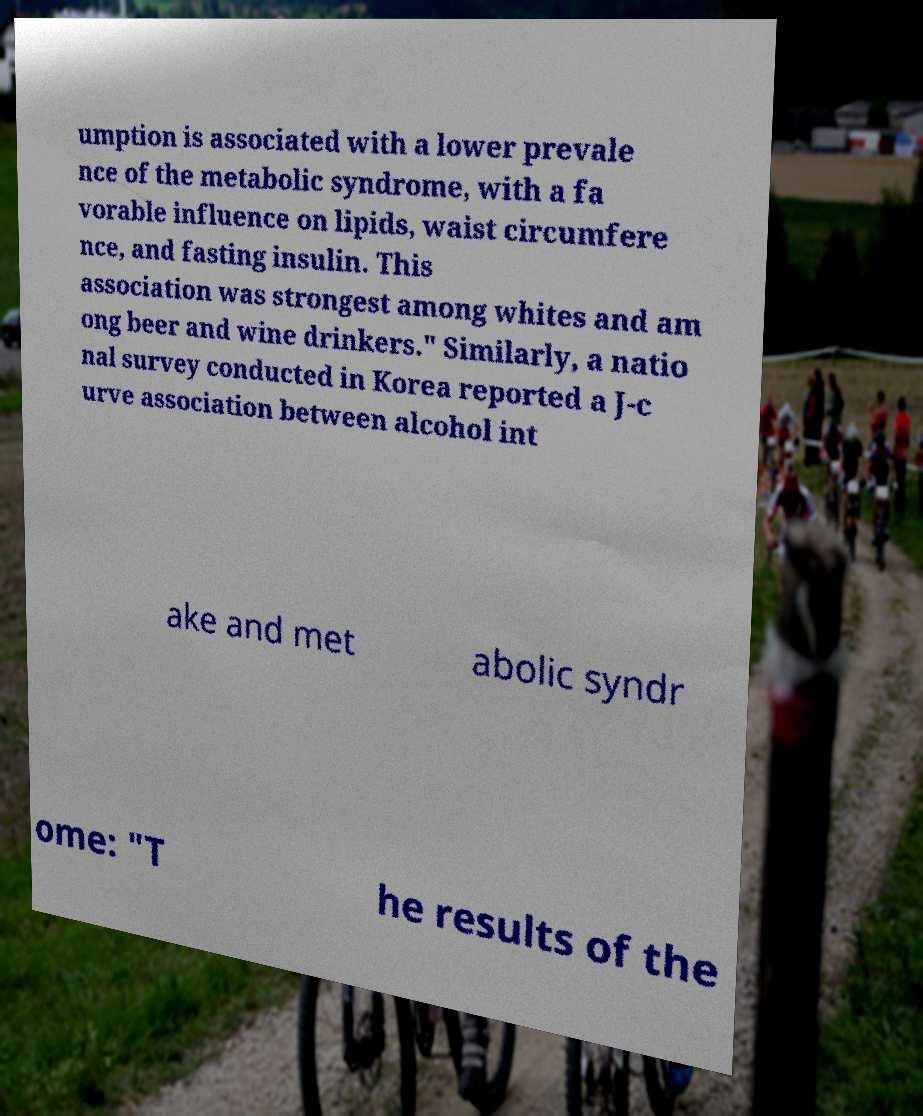For documentation purposes, I need the text within this image transcribed. Could you provide that? umption is associated with a lower prevale nce of the metabolic syndrome, with a fa vorable influence on lipids, waist circumfere nce, and fasting insulin. This association was strongest among whites and am ong beer and wine drinkers." Similarly, a natio nal survey conducted in Korea reported a J-c urve association between alcohol int ake and met abolic syndr ome: "T he results of the 